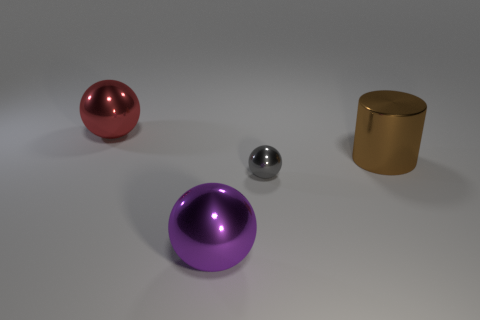Is the number of big cylinders the same as the number of shiny things?
Ensure brevity in your answer.  No. There is a metal object behind the brown metallic cylinder; is it the same size as the big purple sphere?
Your answer should be very brief. Yes. How many other things are there of the same size as the red metallic ball?
Ensure brevity in your answer.  2. The small object has what color?
Your answer should be compact. Gray. What is the material of the big sphere that is right of the red metal sphere?
Provide a succinct answer. Metal. Are there the same number of brown objects that are to the left of the small gray thing and big purple balls?
Offer a very short reply. No. Do the tiny gray metal object and the purple thing have the same shape?
Make the answer very short. Yes. Are there any other things that are the same color as the large shiny cylinder?
Make the answer very short. No. There is a metallic thing that is both behind the tiny gray sphere and to the right of the big purple shiny ball; what shape is it?
Offer a very short reply. Cylinder. Are there the same number of small balls that are behind the small metallic thing and large purple metallic spheres to the right of the big purple metallic sphere?
Ensure brevity in your answer.  Yes. 